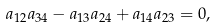<formula> <loc_0><loc_0><loc_500><loc_500>a _ { 1 2 } a _ { 3 4 } - a _ { 1 3 } a _ { 2 4 } + a _ { 1 4 } a _ { 2 3 } = 0 ,</formula> 